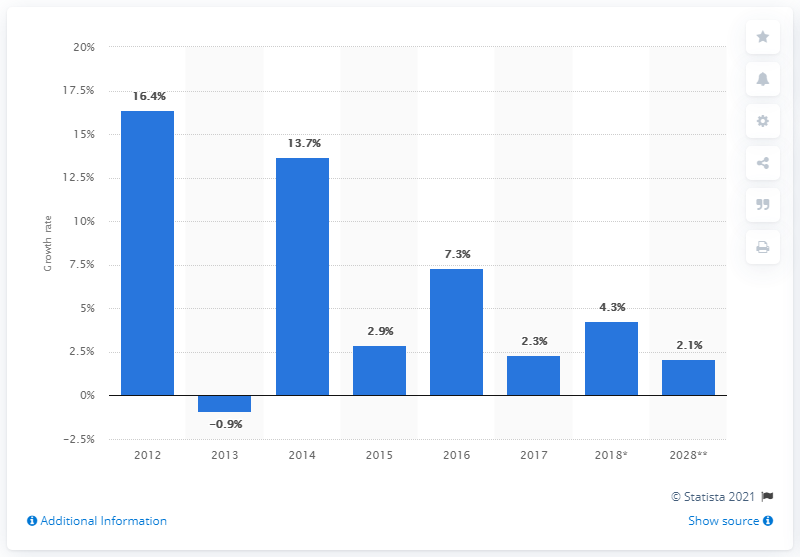Which year shows a negative blue bar? In the provided bar chart, the year 2013 is depicted with a negative growth rate, represented by the blue bar below the 0% baseline. This indicates a contraction in the measured data for that year. 